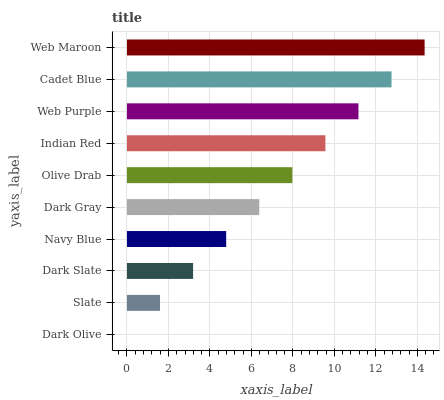Is Dark Olive the minimum?
Answer yes or no. Yes. Is Web Maroon the maximum?
Answer yes or no. Yes. Is Slate the minimum?
Answer yes or no. No. Is Slate the maximum?
Answer yes or no. No. Is Slate greater than Dark Olive?
Answer yes or no. Yes. Is Dark Olive less than Slate?
Answer yes or no. Yes. Is Dark Olive greater than Slate?
Answer yes or no. No. Is Slate less than Dark Olive?
Answer yes or no. No. Is Olive Drab the high median?
Answer yes or no. Yes. Is Dark Gray the low median?
Answer yes or no. Yes. Is Cadet Blue the high median?
Answer yes or no. No. Is Web Maroon the low median?
Answer yes or no. No. 